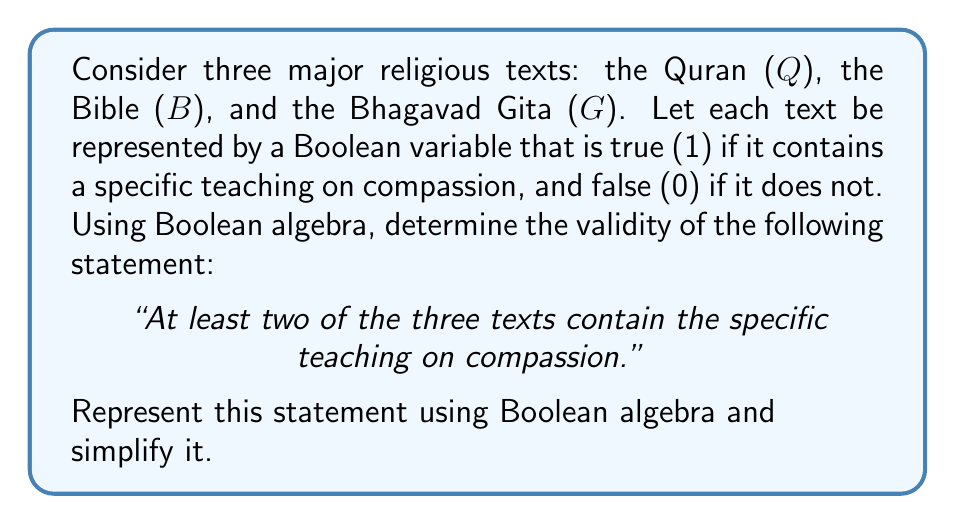Can you solve this math problem? Let's approach this step-by-step:

1) First, we need to represent "at least two of the three texts contain the teaching" in Boolean algebra. This can be done using the following expression:

   $$(Q \land B) \lor (Q \land G) \lor (B \land G)$$

2) This expression means that either Q and B are true, or Q and G are true, or B and G are true.

3) We can simplify this expression using Boolean algebra laws:

   $$(Q \land B) \lor (Q \land G) \lor (B \land G)$$
   $$= Q(B \lor G) \lor (B \land G)$$ (Distributive law)
   $$= QB \lor QG \lor BG$$ (Removing parentheses)

4) This simplified form, $QB \lor QG \lor BG$, represents our original statement in Boolean algebra.

5) To further analyze this, we could create a truth table:

   | Q | B | G | QB | QG | BG | QB ∨ QG ∨ BG |
   |---|---|---|----|----|----|--------------|
   | 0 | 0 | 0 |  0 |  0 |  0 |      0       |
   | 0 | 0 | 1 |  0 |  0 |  0 |      0       |
   | 0 | 1 | 0 |  0 |  0 |  0 |      0       |
   | 0 | 1 | 1 |  0 |  0 |  1 |      1       |
   | 1 | 0 | 0 |  0 |  0 |  0 |      0       |
   | 1 | 0 | 1 |  0 |  1 |  0 |      1       |
   | 1 | 1 | 0 |  1 |  0 |  0 |      1       |
   | 1 | 1 | 1 |  1 |  1 |  1 |      1       |

6) The truth table confirms that the expression is true (1) whenever at least two of the variables are true, which aligns with our original statement.
Answer: $QB \lor QG \lor BG$ 